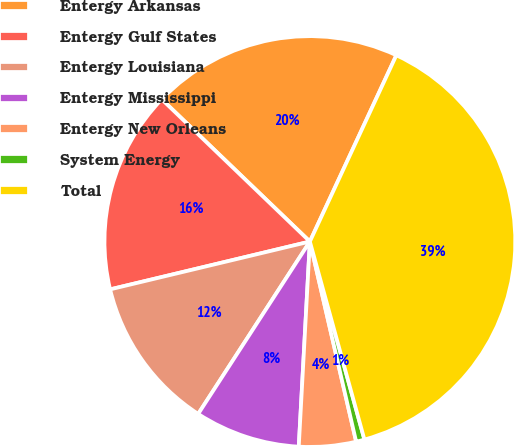<chart> <loc_0><loc_0><loc_500><loc_500><pie_chart><fcel>Entergy Arkansas<fcel>Entergy Gulf States<fcel>Entergy Louisiana<fcel>Entergy Mississippi<fcel>Entergy New Orleans<fcel>System Energy<fcel>Total<nl><fcel>19.74%<fcel>15.92%<fcel>12.11%<fcel>8.29%<fcel>4.48%<fcel>0.66%<fcel>38.81%<nl></chart> 